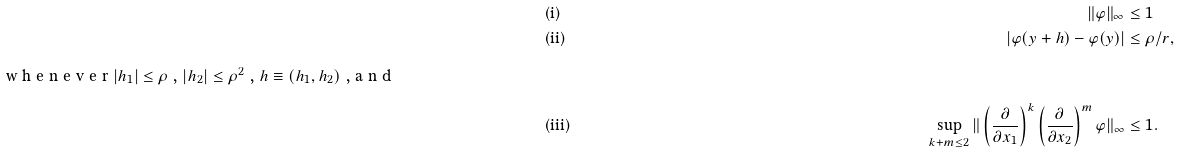<formula> <loc_0><loc_0><loc_500><loc_500>& \text {(i)} & \| \varphi \| _ { \infty } & \leq 1 \\ & \text {(ii)} & | \varphi ( y + h ) - \varphi ( y ) | & \leq \rho / r , \\ \intertext { w h e n e v e r $ | h _ { 1 } | \leq \rho $ , $ | h _ { 2 } | \leq \rho ^ { 2 } $ , $ h \equiv ( h _ { 1 } , h _ { 2 } ) $ , a n d } & \text {(iii)} & \sup _ { k + m \leq 2 } \| \left ( \frac { \partial } { \partial x _ { 1 } } \right ) ^ { k } \left ( \frac { \partial } { \partial x _ { 2 } } \right ) ^ { m } \varphi \| _ { \infty } & \leq 1 .</formula> 